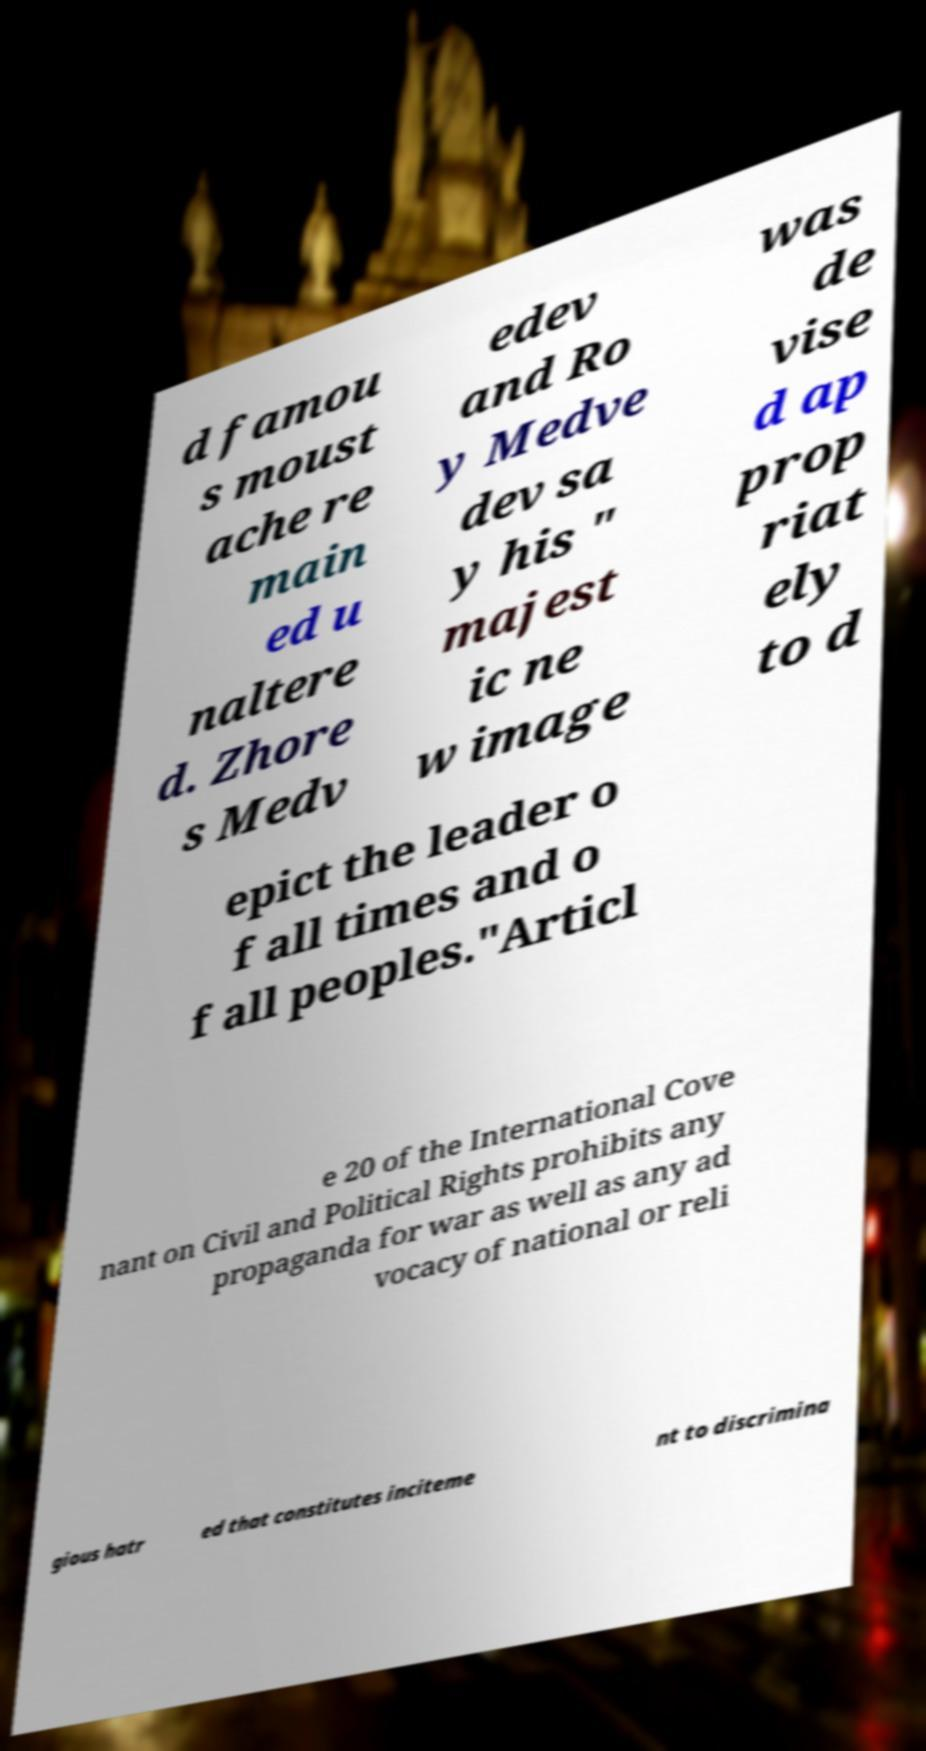Can you read and provide the text displayed in the image?This photo seems to have some interesting text. Can you extract and type it out for me? d famou s moust ache re main ed u naltere d. Zhore s Medv edev and Ro y Medve dev sa y his " majest ic ne w image was de vise d ap prop riat ely to d epict the leader o f all times and o f all peoples."Articl e 20 of the International Cove nant on Civil and Political Rights prohibits any propaganda for war as well as any ad vocacy of national or reli gious hatr ed that constitutes inciteme nt to discrimina 